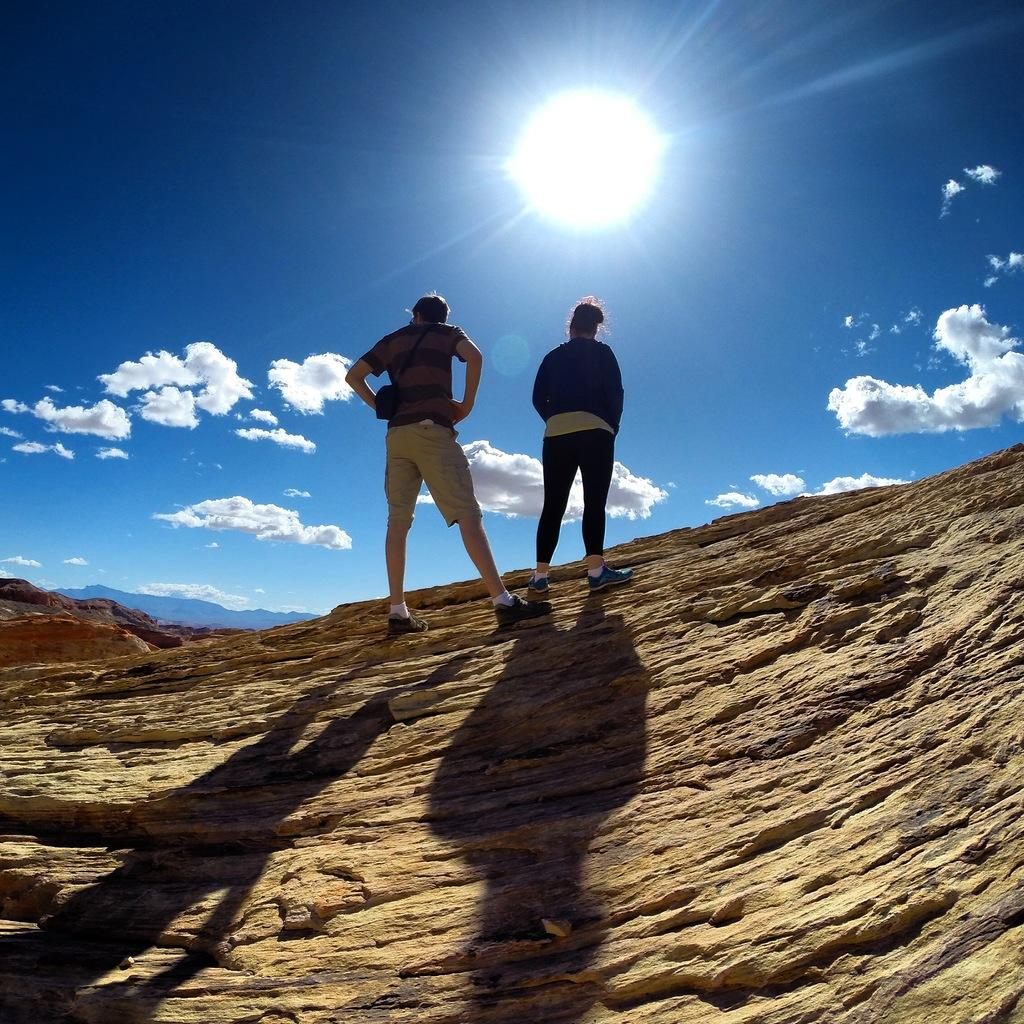How many people are in the image? There are two people in the image, a man and a woman. Where are the man and woman located in the image? Both the man and woman are standing on a rock mountain. What can be seen in the sky in the image? The sky is visible in the image, and it is blue with clouds present. What type of twig is the man holding in the image? There is no twig present in the image; the man and woman are standing on a rock mountain without any visible objects in their hands. 